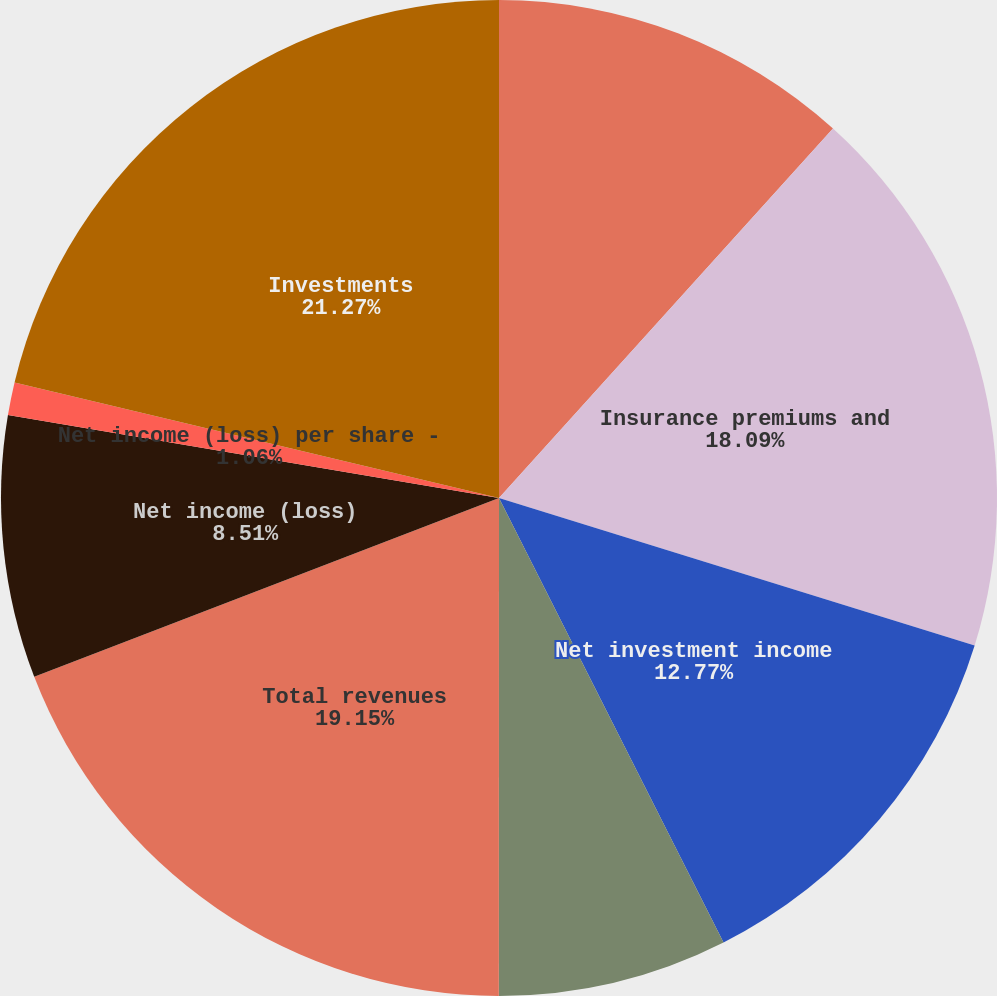Convert chart. <chart><loc_0><loc_0><loc_500><loc_500><pie_chart><fcel>( in millions except per share<fcel>Insurance premiums and<fcel>Net investment income<fcel>Realized capital gains and<fcel>Total revenues<fcel>Net income (loss)<fcel>Net income (loss) per share -<fcel>Cash dividends declared per<fcel>Investments<nl><fcel>11.7%<fcel>18.09%<fcel>12.77%<fcel>7.45%<fcel>19.15%<fcel>8.51%<fcel>1.06%<fcel>0.0%<fcel>21.28%<nl></chart> 